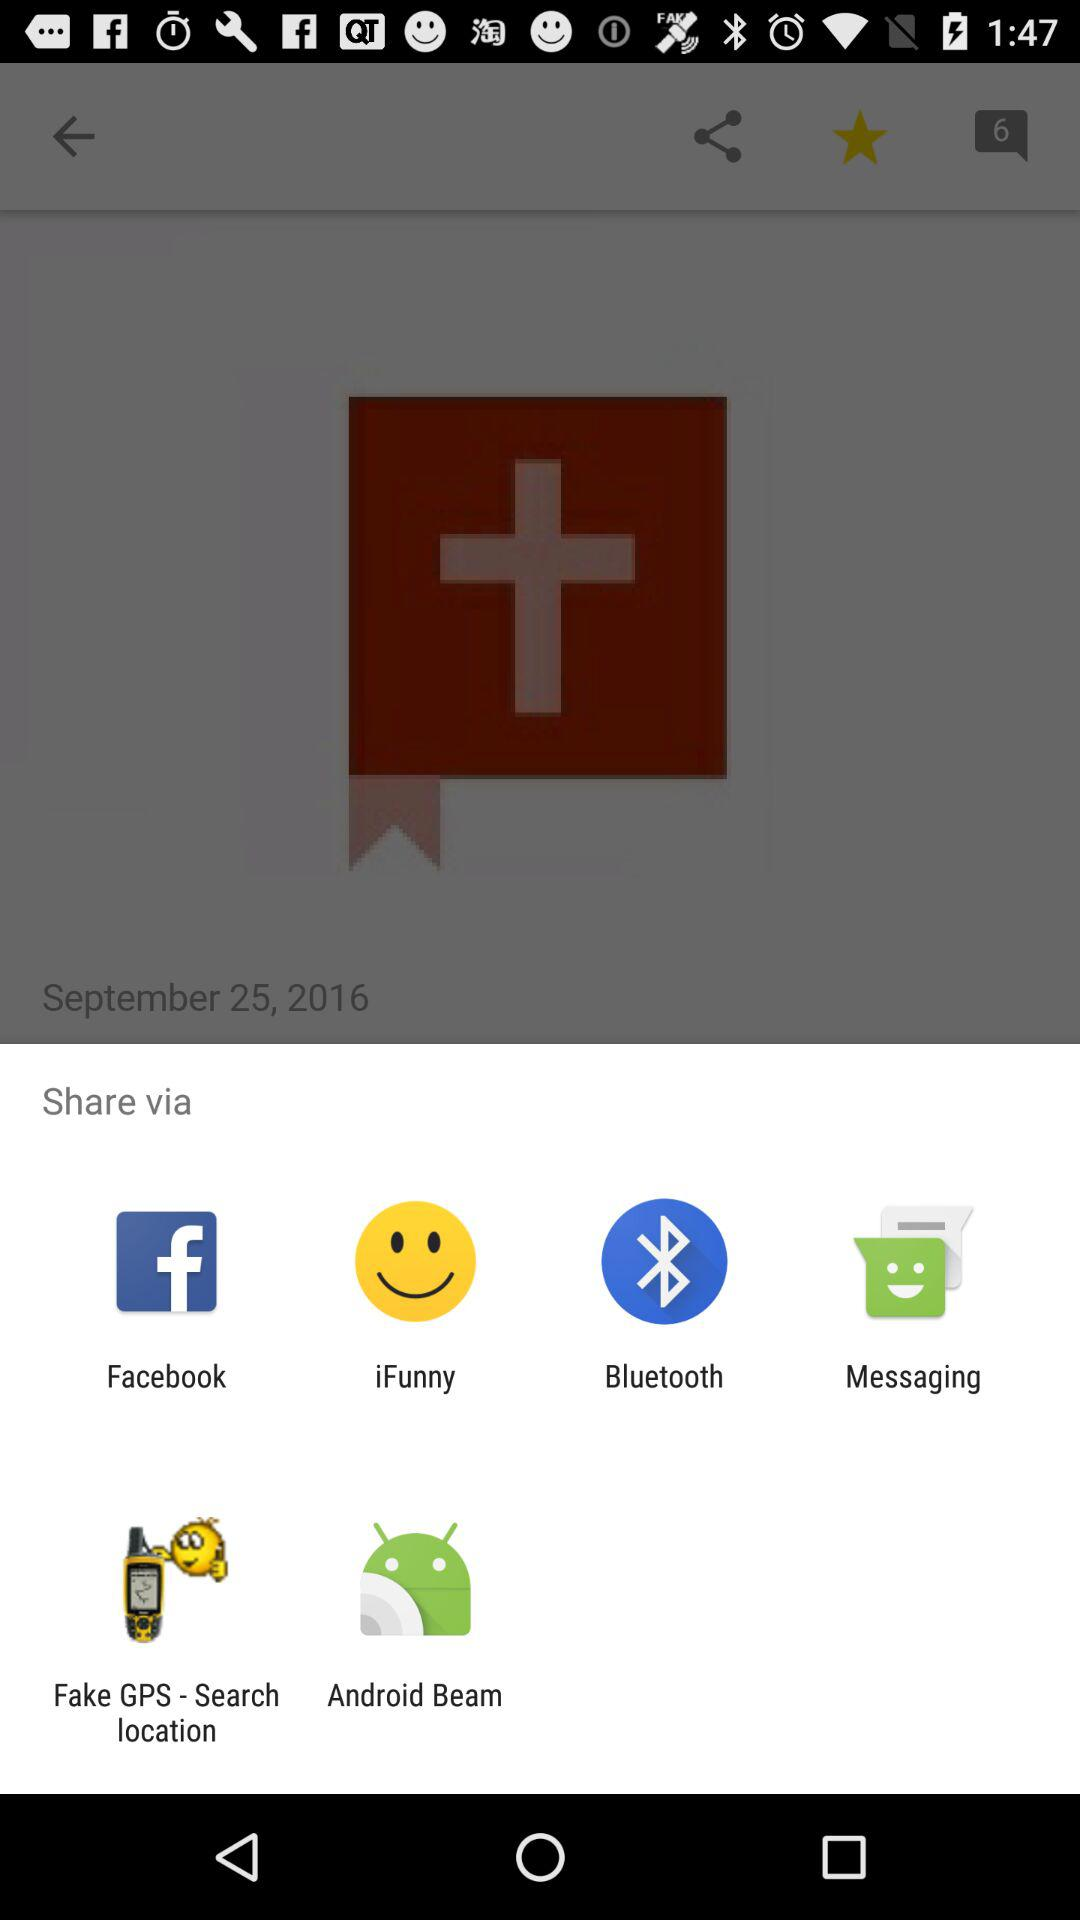What is the date? The date is September 25, 2016. 